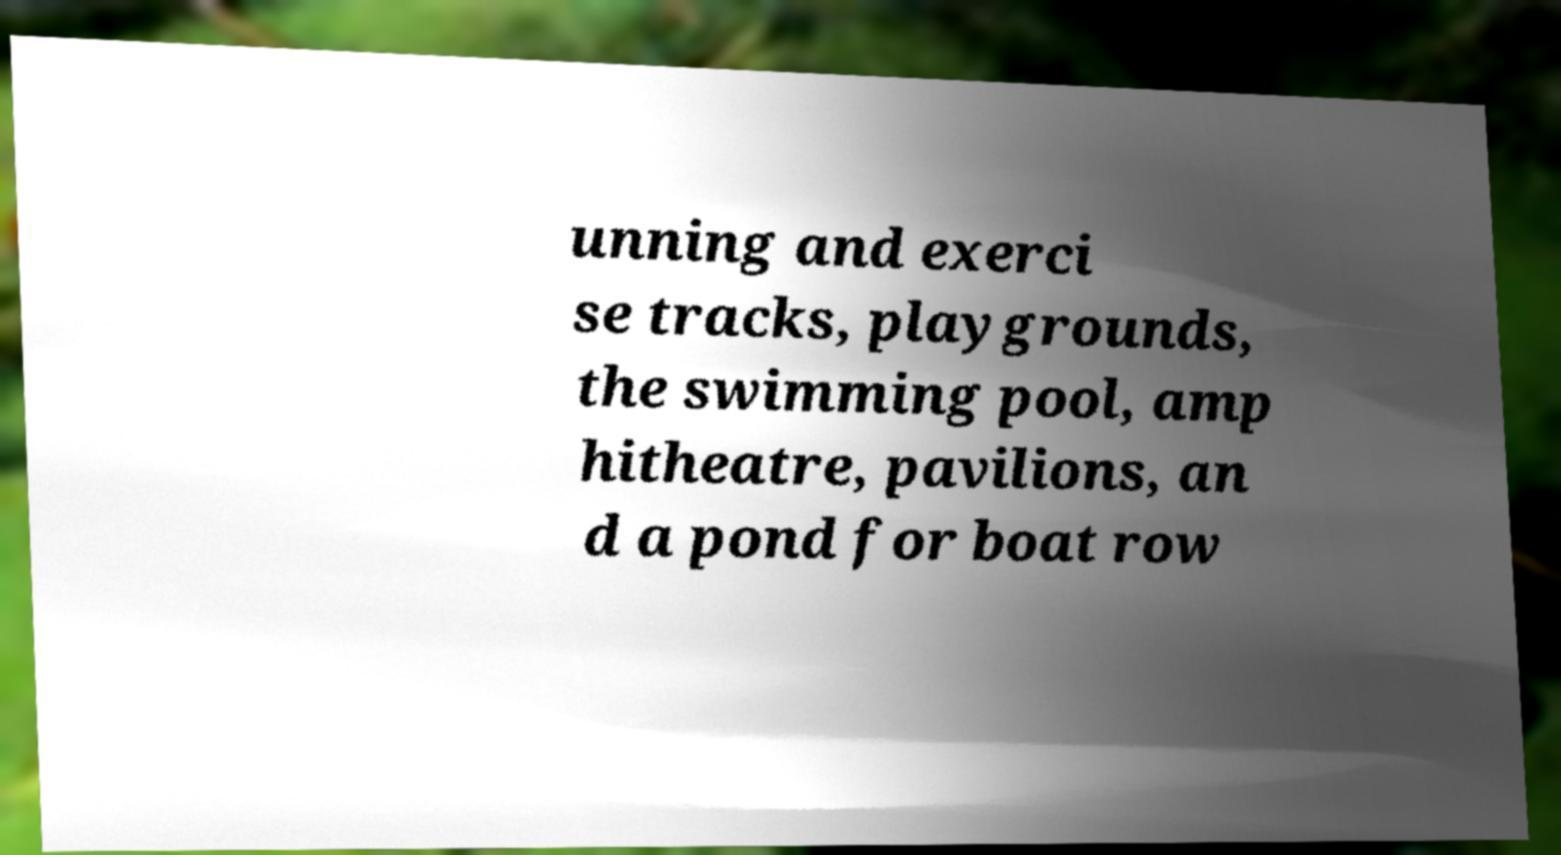What messages or text are displayed in this image? I need them in a readable, typed format. unning and exerci se tracks, playgrounds, the swimming pool, amp hitheatre, pavilions, an d a pond for boat row 